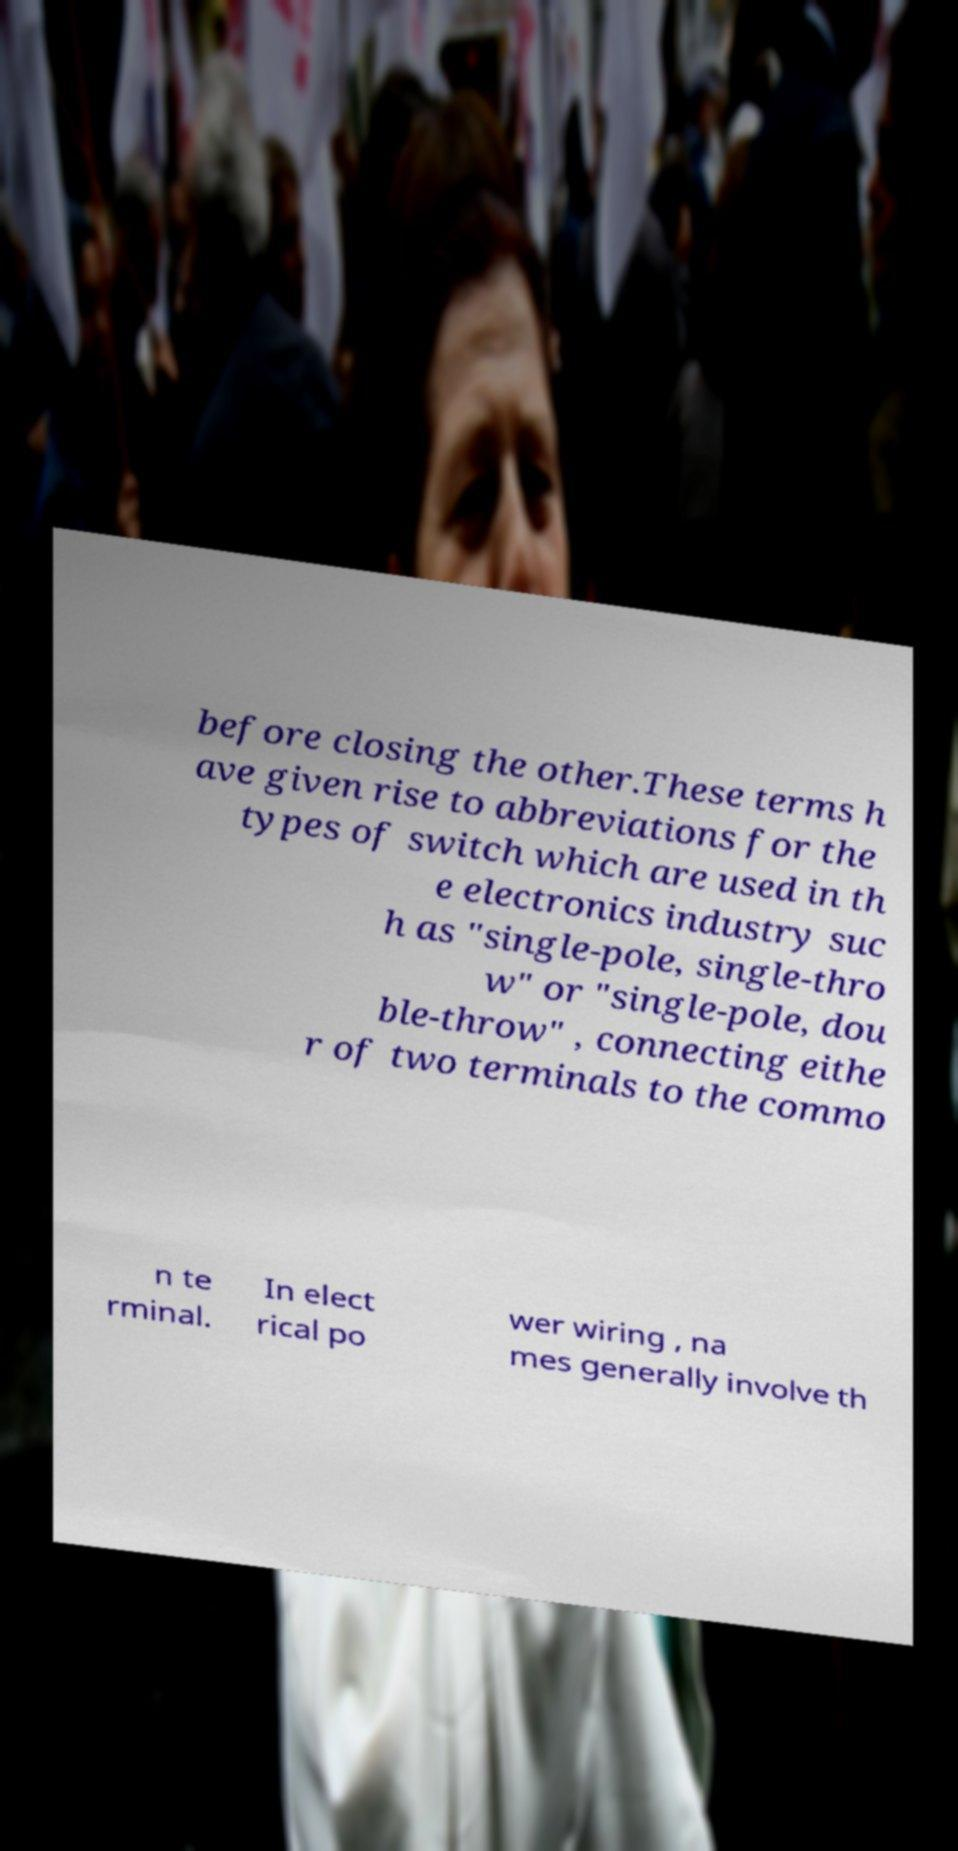Can you accurately transcribe the text from the provided image for me? before closing the other.These terms h ave given rise to abbreviations for the types of switch which are used in th e electronics industry suc h as "single-pole, single-thro w" or "single-pole, dou ble-throw" , connecting eithe r of two terminals to the commo n te rminal. In elect rical po wer wiring , na mes generally involve th 